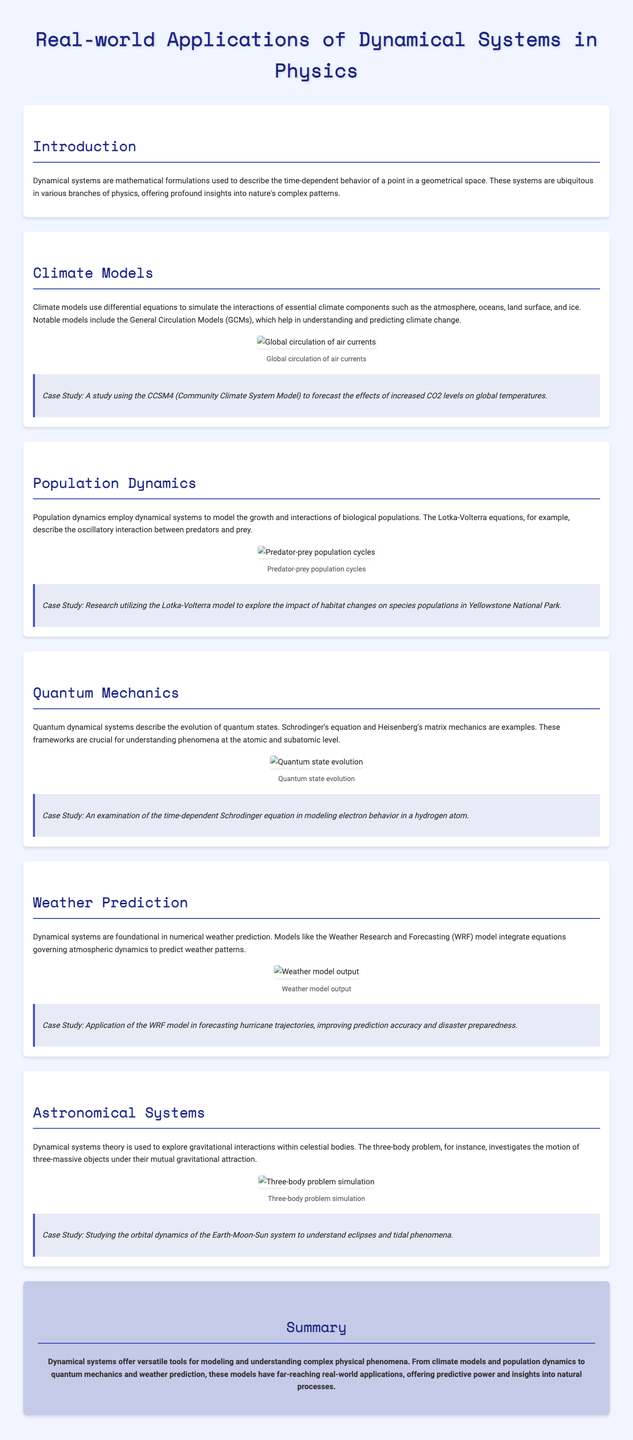What is the title of the infographic? The title is prominently displayed at the top of the document, providing the main subject of the infographic.
Answer: Real-world Applications of Dynamical Systems in Physics Which model is used in climate studies? This model is explicitly mentioned in the section on Climate Models, which highlights its significance in studying climate change.
Answer: General Circulation Models (GCMs) What mathematical equations are used in population dynamics? The document identifies specific equations relevant to modeling biological populations, found in the Population Dynamics section.
Answer: Lotka-Volterra equations Which equation describes quantum state evolution? This equation is referenced in the Quantum Mechanics section as essential for understanding phenomena at the atomic level.
Answer: Schrodinger's equation What does the WRF model predict? This model's application is discussed in the Weather Prediction section, demonstrating its role in forecasting specific meteorological events.
Answer: Hurricane trajectories What is explored in astronomical systems using dynamical systems theory? The text explains the focus of research in the section on Astronomical Systems, clarifying the context of its application.
Answer: Gravitational interactions How is habitat change studied in the context of population dynamics? The specific research focus is mentioned in the case study within the Population Dynamics section, connecting habitat changes to population impacts.
Answer: Yellowstone National Park What is the visual representation of the three-body problem in the document? A specific image related to this problem is present in the Astronomical Systems section, supporting the explanation with a visual component.
Answer: Three-body problem simulation 